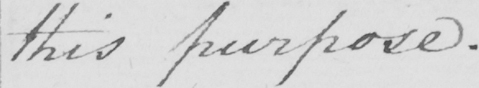What does this handwritten line say? this purpose . 